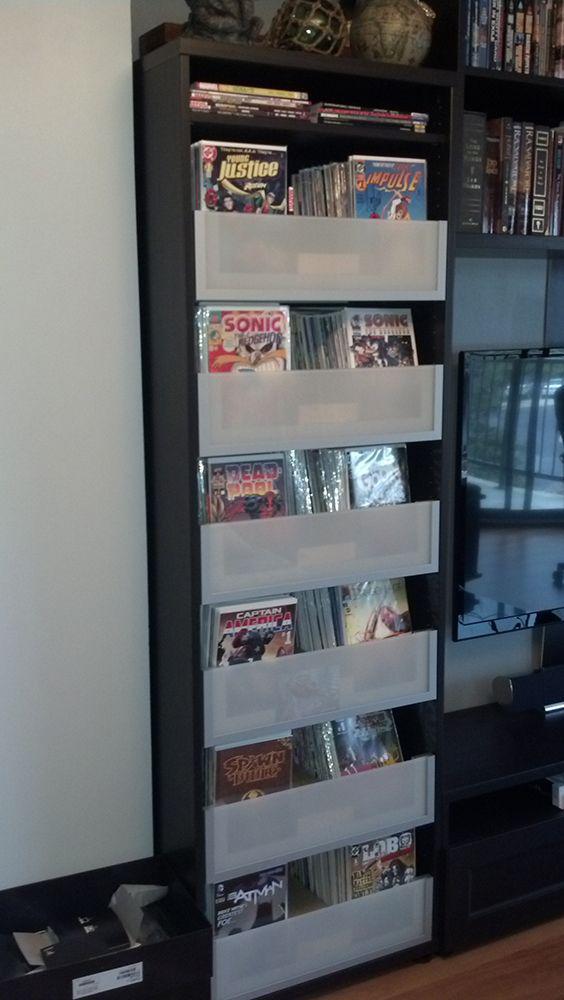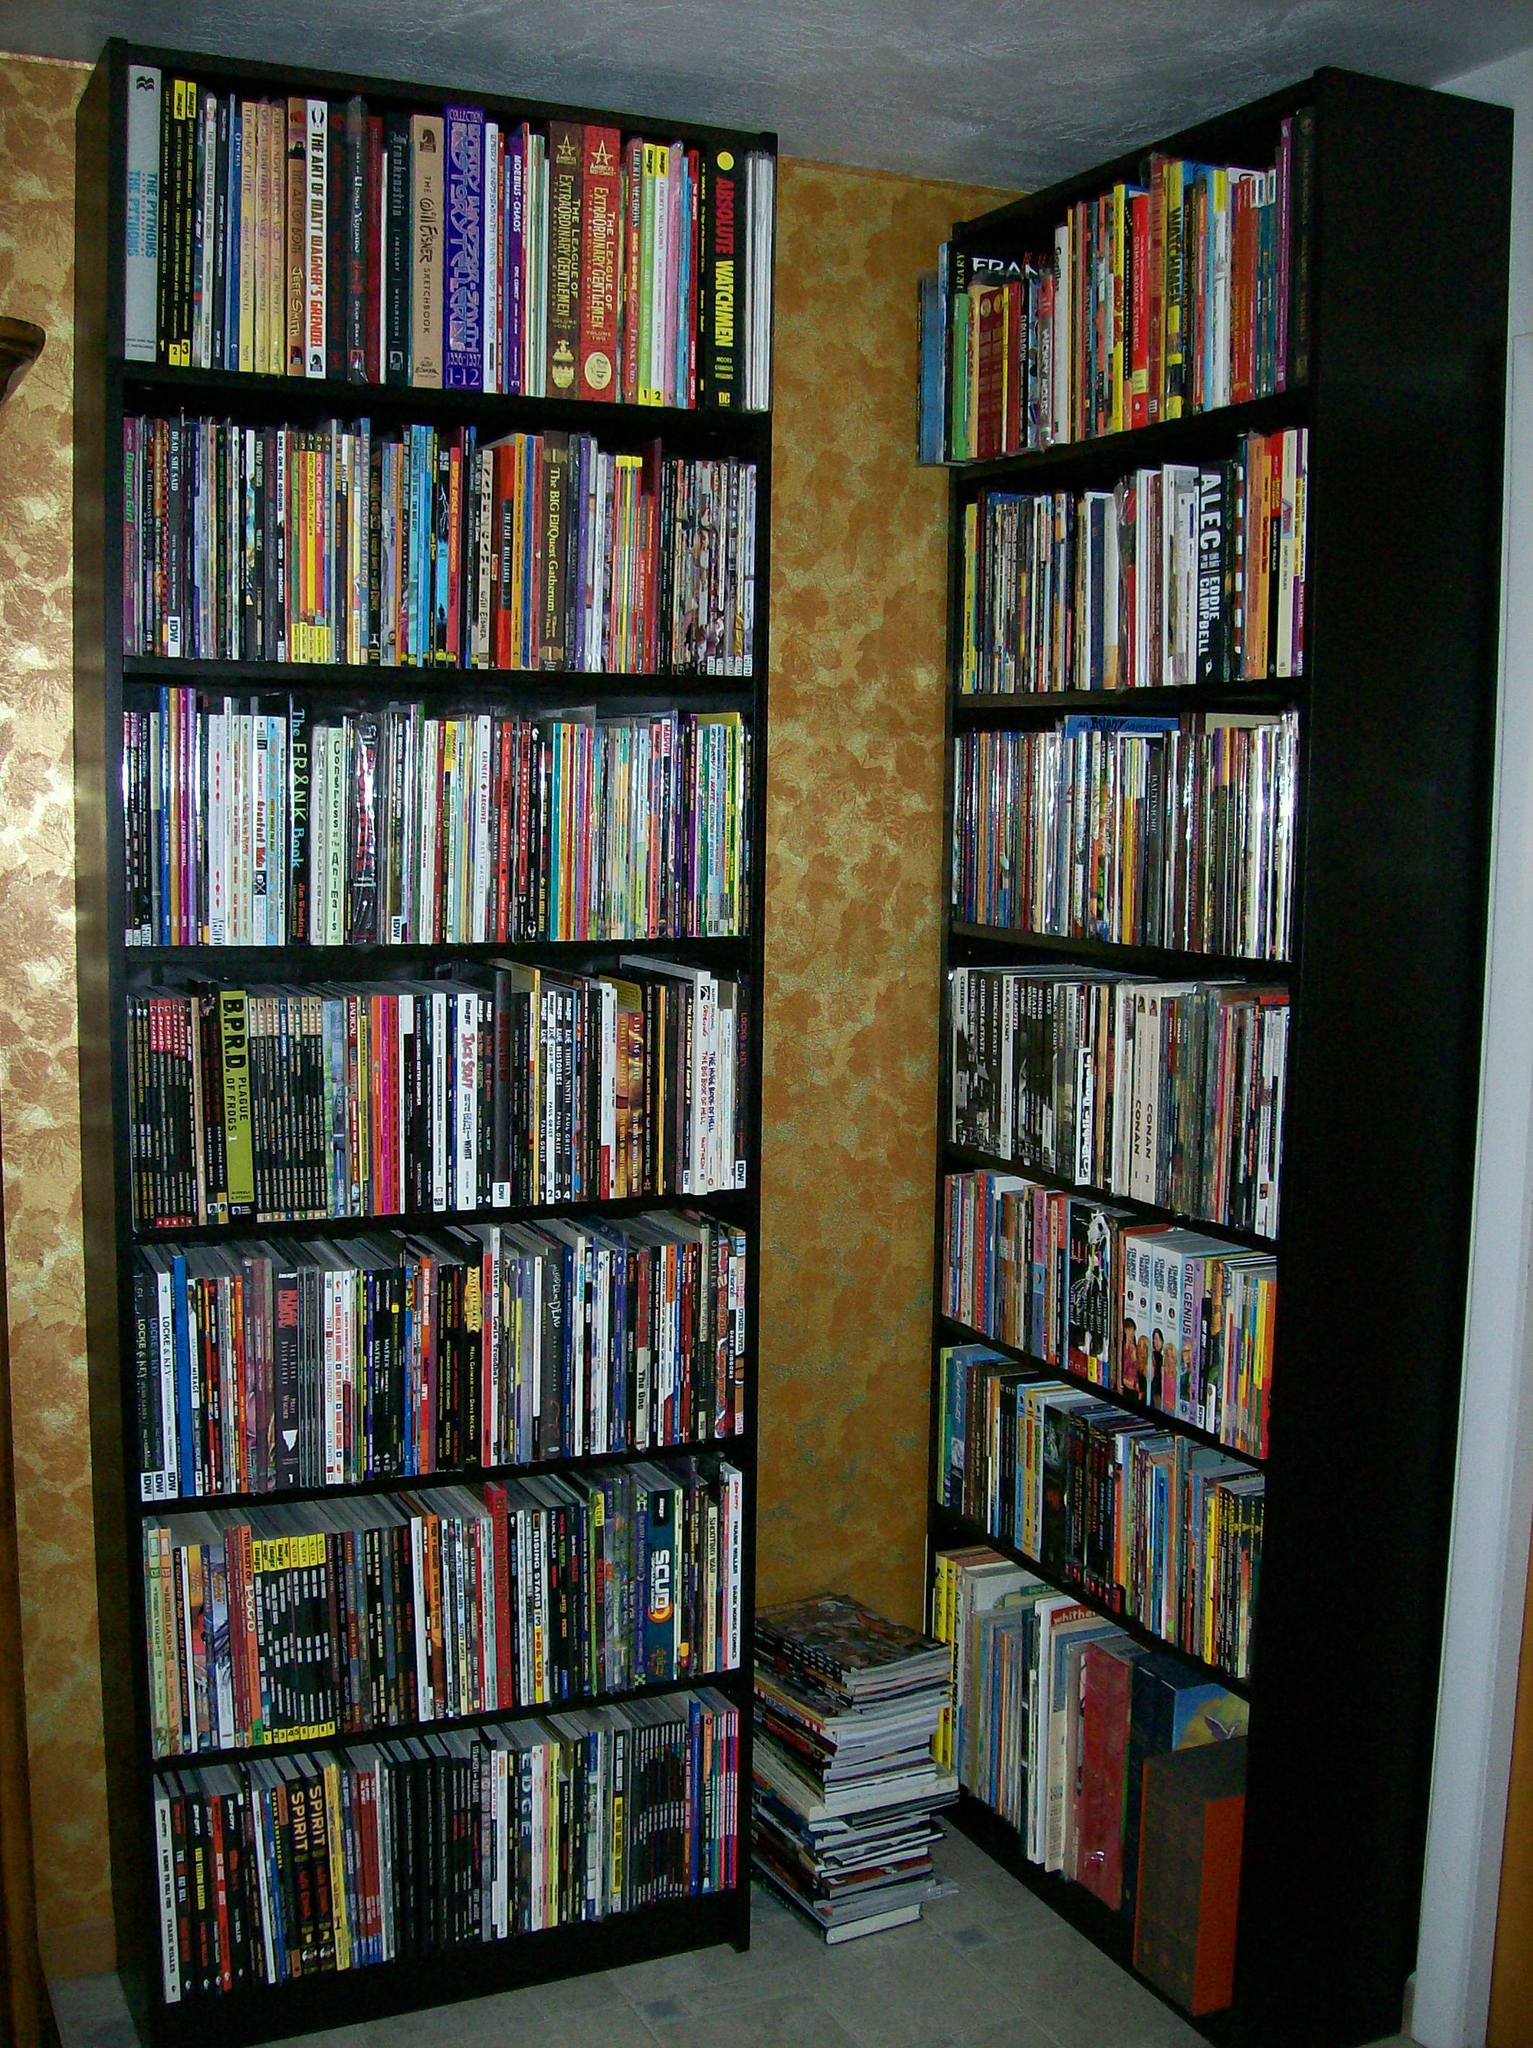The first image is the image on the left, the second image is the image on the right. Evaluate the accuracy of this statement regarding the images: "There are no fewer than four framed images in the image on the right.". Is it true? Answer yes or no. No. The first image is the image on the left, the second image is the image on the right. Evaluate the accuracy of this statement regarding the images: "A window lets light into the area near the books.". Is it true? Answer yes or no. No. 